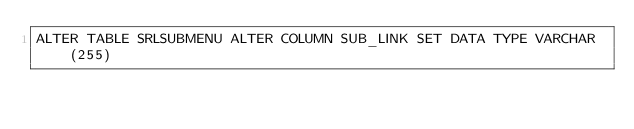<code> <loc_0><loc_0><loc_500><loc_500><_SQL_>ALTER TABLE SRLSUBMENU ALTER COLUMN SUB_LINK SET DATA TYPE VARCHAR(255)
</code> 